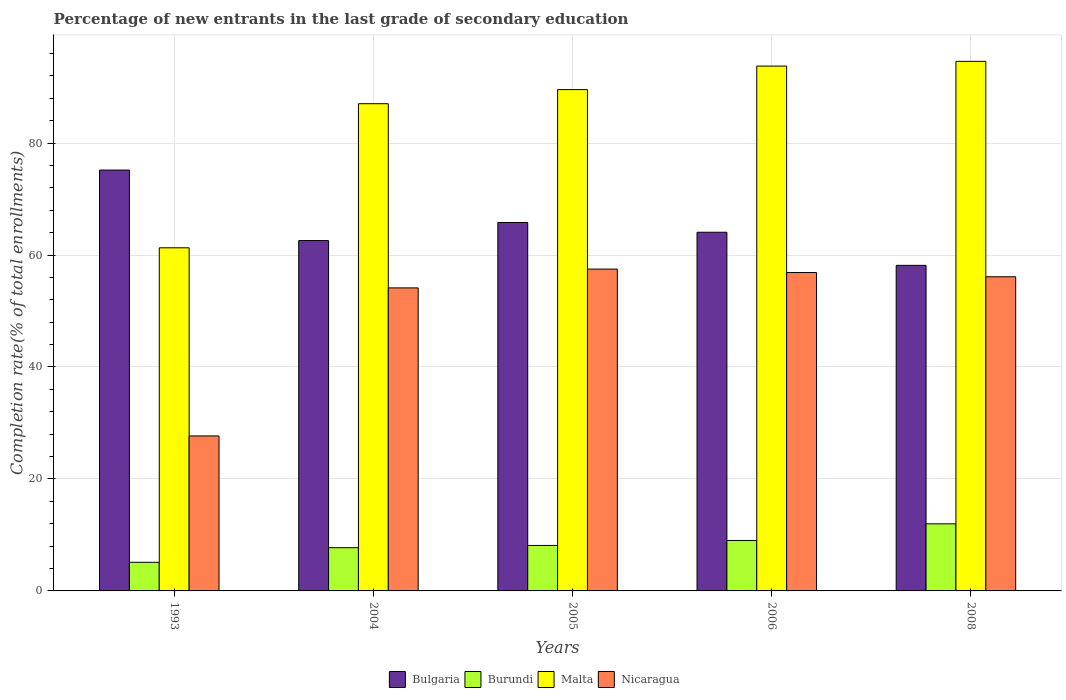Are the number of bars on each tick of the X-axis equal?
Ensure brevity in your answer.  Yes. What is the label of the 3rd group of bars from the left?
Ensure brevity in your answer.  2005. In how many cases, is the number of bars for a given year not equal to the number of legend labels?
Ensure brevity in your answer.  0. What is the percentage of new entrants in Burundi in 2008?
Give a very brief answer. 11.98. Across all years, what is the maximum percentage of new entrants in Nicaragua?
Your answer should be compact. 57.49. Across all years, what is the minimum percentage of new entrants in Bulgaria?
Provide a succinct answer. 58.15. What is the total percentage of new entrants in Burundi in the graph?
Your answer should be compact. 41.95. What is the difference between the percentage of new entrants in Malta in 2005 and that in 2008?
Give a very brief answer. -5.04. What is the difference between the percentage of new entrants in Burundi in 1993 and the percentage of new entrants in Bulgaria in 2005?
Offer a terse response. -60.7. What is the average percentage of new entrants in Burundi per year?
Your answer should be very brief. 8.39. In the year 2008, what is the difference between the percentage of new entrants in Bulgaria and percentage of new entrants in Burundi?
Give a very brief answer. 46.17. In how many years, is the percentage of new entrants in Nicaragua greater than 12 %?
Ensure brevity in your answer.  5. What is the ratio of the percentage of new entrants in Burundi in 2005 to that in 2008?
Your answer should be compact. 0.68. Is the difference between the percentage of new entrants in Bulgaria in 2005 and 2008 greater than the difference between the percentage of new entrants in Burundi in 2005 and 2008?
Your answer should be very brief. Yes. What is the difference between the highest and the second highest percentage of new entrants in Malta?
Keep it short and to the point. 0.84. What is the difference between the highest and the lowest percentage of new entrants in Malta?
Offer a very short reply. 33.31. In how many years, is the percentage of new entrants in Nicaragua greater than the average percentage of new entrants in Nicaragua taken over all years?
Your response must be concise. 4. Is the sum of the percentage of new entrants in Burundi in 2004 and 2008 greater than the maximum percentage of new entrants in Nicaragua across all years?
Ensure brevity in your answer.  No. What does the 1st bar from the left in 2005 represents?
Give a very brief answer. Bulgaria. Is it the case that in every year, the sum of the percentage of new entrants in Burundi and percentage of new entrants in Bulgaria is greater than the percentage of new entrants in Nicaragua?
Offer a terse response. Yes. How many bars are there?
Offer a very short reply. 20. Are all the bars in the graph horizontal?
Provide a succinct answer. No. How many years are there in the graph?
Your response must be concise. 5. What is the difference between two consecutive major ticks on the Y-axis?
Your answer should be compact. 20. How are the legend labels stacked?
Your answer should be compact. Horizontal. What is the title of the graph?
Provide a short and direct response. Percentage of new entrants in the last grade of secondary education. Does "Europe(all income levels)" appear as one of the legend labels in the graph?
Offer a very short reply. No. What is the label or title of the X-axis?
Give a very brief answer. Years. What is the label or title of the Y-axis?
Give a very brief answer. Completion rate(% of total enrollments). What is the Completion rate(% of total enrollments) in Bulgaria in 1993?
Ensure brevity in your answer.  75.18. What is the Completion rate(% of total enrollments) in Burundi in 1993?
Offer a terse response. 5.11. What is the Completion rate(% of total enrollments) of Malta in 1993?
Keep it short and to the point. 61.29. What is the Completion rate(% of total enrollments) in Nicaragua in 1993?
Provide a short and direct response. 27.68. What is the Completion rate(% of total enrollments) of Bulgaria in 2004?
Provide a short and direct response. 62.58. What is the Completion rate(% of total enrollments) in Burundi in 2004?
Give a very brief answer. 7.72. What is the Completion rate(% of total enrollments) of Malta in 2004?
Keep it short and to the point. 87.03. What is the Completion rate(% of total enrollments) in Nicaragua in 2004?
Ensure brevity in your answer.  54.13. What is the Completion rate(% of total enrollments) in Bulgaria in 2005?
Your answer should be compact. 65.81. What is the Completion rate(% of total enrollments) in Burundi in 2005?
Provide a short and direct response. 8.12. What is the Completion rate(% of total enrollments) in Malta in 2005?
Offer a very short reply. 89.55. What is the Completion rate(% of total enrollments) in Nicaragua in 2005?
Provide a short and direct response. 57.49. What is the Completion rate(% of total enrollments) in Bulgaria in 2006?
Provide a short and direct response. 64.07. What is the Completion rate(% of total enrollments) of Burundi in 2006?
Offer a terse response. 9.01. What is the Completion rate(% of total enrollments) of Malta in 2006?
Provide a succinct answer. 93.75. What is the Completion rate(% of total enrollments) of Nicaragua in 2006?
Provide a succinct answer. 56.87. What is the Completion rate(% of total enrollments) of Bulgaria in 2008?
Your answer should be very brief. 58.15. What is the Completion rate(% of total enrollments) of Burundi in 2008?
Offer a terse response. 11.98. What is the Completion rate(% of total enrollments) in Malta in 2008?
Provide a short and direct response. 94.59. What is the Completion rate(% of total enrollments) in Nicaragua in 2008?
Keep it short and to the point. 56.12. Across all years, what is the maximum Completion rate(% of total enrollments) in Bulgaria?
Provide a succinct answer. 75.18. Across all years, what is the maximum Completion rate(% of total enrollments) of Burundi?
Make the answer very short. 11.98. Across all years, what is the maximum Completion rate(% of total enrollments) in Malta?
Offer a terse response. 94.59. Across all years, what is the maximum Completion rate(% of total enrollments) in Nicaragua?
Ensure brevity in your answer.  57.49. Across all years, what is the minimum Completion rate(% of total enrollments) in Bulgaria?
Make the answer very short. 58.15. Across all years, what is the minimum Completion rate(% of total enrollments) of Burundi?
Give a very brief answer. 5.11. Across all years, what is the minimum Completion rate(% of total enrollments) in Malta?
Make the answer very short. 61.29. Across all years, what is the minimum Completion rate(% of total enrollments) of Nicaragua?
Keep it short and to the point. 27.68. What is the total Completion rate(% of total enrollments) in Bulgaria in the graph?
Offer a very short reply. 325.79. What is the total Completion rate(% of total enrollments) in Burundi in the graph?
Ensure brevity in your answer.  41.95. What is the total Completion rate(% of total enrollments) of Malta in the graph?
Make the answer very short. 426.2. What is the total Completion rate(% of total enrollments) of Nicaragua in the graph?
Your response must be concise. 252.28. What is the difference between the Completion rate(% of total enrollments) in Bulgaria in 1993 and that in 2004?
Provide a succinct answer. 12.59. What is the difference between the Completion rate(% of total enrollments) in Burundi in 1993 and that in 2004?
Keep it short and to the point. -2.61. What is the difference between the Completion rate(% of total enrollments) of Malta in 1993 and that in 2004?
Your answer should be very brief. -25.74. What is the difference between the Completion rate(% of total enrollments) in Nicaragua in 1993 and that in 2004?
Your answer should be very brief. -26.45. What is the difference between the Completion rate(% of total enrollments) in Bulgaria in 1993 and that in 2005?
Keep it short and to the point. 9.37. What is the difference between the Completion rate(% of total enrollments) in Burundi in 1993 and that in 2005?
Provide a short and direct response. -3.01. What is the difference between the Completion rate(% of total enrollments) of Malta in 1993 and that in 2005?
Give a very brief answer. -28.26. What is the difference between the Completion rate(% of total enrollments) in Nicaragua in 1993 and that in 2005?
Provide a short and direct response. -29.81. What is the difference between the Completion rate(% of total enrollments) of Bulgaria in 1993 and that in 2006?
Offer a very short reply. 11.11. What is the difference between the Completion rate(% of total enrollments) of Burundi in 1993 and that in 2006?
Give a very brief answer. -3.9. What is the difference between the Completion rate(% of total enrollments) in Malta in 1993 and that in 2006?
Provide a succinct answer. -32.46. What is the difference between the Completion rate(% of total enrollments) of Nicaragua in 1993 and that in 2006?
Ensure brevity in your answer.  -29.19. What is the difference between the Completion rate(% of total enrollments) of Bulgaria in 1993 and that in 2008?
Your answer should be compact. 17.02. What is the difference between the Completion rate(% of total enrollments) of Burundi in 1993 and that in 2008?
Your answer should be very brief. -6.87. What is the difference between the Completion rate(% of total enrollments) of Malta in 1993 and that in 2008?
Your response must be concise. -33.31. What is the difference between the Completion rate(% of total enrollments) in Nicaragua in 1993 and that in 2008?
Provide a succinct answer. -28.44. What is the difference between the Completion rate(% of total enrollments) of Bulgaria in 2004 and that in 2005?
Offer a very short reply. -3.23. What is the difference between the Completion rate(% of total enrollments) of Burundi in 2004 and that in 2005?
Offer a terse response. -0.4. What is the difference between the Completion rate(% of total enrollments) in Malta in 2004 and that in 2005?
Ensure brevity in your answer.  -2.52. What is the difference between the Completion rate(% of total enrollments) of Nicaragua in 2004 and that in 2005?
Provide a short and direct response. -3.36. What is the difference between the Completion rate(% of total enrollments) in Bulgaria in 2004 and that in 2006?
Ensure brevity in your answer.  -1.49. What is the difference between the Completion rate(% of total enrollments) in Burundi in 2004 and that in 2006?
Ensure brevity in your answer.  -1.29. What is the difference between the Completion rate(% of total enrollments) of Malta in 2004 and that in 2006?
Provide a short and direct response. -6.72. What is the difference between the Completion rate(% of total enrollments) of Nicaragua in 2004 and that in 2006?
Make the answer very short. -2.75. What is the difference between the Completion rate(% of total enrollments) in Bulgaria in 2004 and that in 2008?
Keep it short and to the point. 4.43. What is the difference between the Completion rate(% of total enrollments) in Burundi in 2004 and that in 2008?
Your response must be concise. -4.26. What is the difference between the Completion rate(% of total enrollments) in Malta in 2004 and that in 2008?
Provide a succinct answer. -7.57. What is the difference between the Completion rate(% of total enrollments) of Nicaragua in 2004 and that in 2008?
Your answer should be very brief. -1.99. What is the difference between the Completion rate(% of total enrollments) of Bulgaria in 2005 and that in 2006?
Your response must be concise. 1.74. What is the difference between the Completion rate(% of total enrollments) in Burundi in 2005 and that in 2006?
Provide a short and direct response. -0.89. What is the difference between the Completion rate(% of total enrollments) of Malta in 2005 and that in 2006?
Give a very brief answer. -4.2. What is the difference between the Completion rate(% of total enrollments) of Nicaragua in 2005 and that in 2006?
Provide a succinct answer. 0.62. What is the difference between the Completion rate(% of total enrollments) in Bulgaria in 2005 and that in 2008?
Provide a succinct answer. 7.65. What is the difference between the Completion rate(% of total enrollments) of Burundi in 2005 and that in 2008?
Provide a short and direct response. -3.86. What is the difference between the Completion rate(% of total enrollments) of Malta in 2005 and that in 2008?
Offer a very short reply. -5.04. What is the difference between the Completion rate(% of total enrollments) of Nicaragua in 2005 and that in 2008?
Offer a terse response. 1.37. What is the difference between the Completion rate(% of total enrollments) in Bulgaria in 2006 and that in 2008?
Keep it short and to the point. 5.91. What is the difference between the Completion rate(% of total enrollments) of Burundi in 2006 and that in 2008?
Your answer should be compact. -2.97. What is the difference between the Completion rate(% of total enrollments) in Malta in 2006 and that in 2008?
Provide a succinct answer. -0.84. What is the difference between the Completion rate(% of total enrollments) of Nicaragua in 2006 and that in 2008?
Your answer should be very brief. 0.76. What is the difference between the Completion rate(% of total enrollments) of Bulgaria in 1993 and the Completion rate(% of total enrollments) of Burundi in 2004?
Give a very brief answer. 67.46. What is the difference between the Completion rate(% of total enrollments) in Bulgaria in 1993 and the Completion rate(% of total enrollments) in Malta in 2004?
Your answer should be very brief. -11.85. What is the difference between the Completion rate(% of total enrollments) of Bulgaria in 1993 and the Completion rate(% of total enrollments) of Nicaragua in 2004?
Make the answer very short. 21.05. What is the difference between the Completion rate(% of total enrollments) of Burundi in 1993 and the Completion rate(% of total enrollments) of Malta in 2004?
Offer a very short reply. -81.91. What is the difference between the Completion rate(% of total enrollments) in Burundi in 1993 and the Completion rate(% of total enrollments) in Nicaragua in 2004?
Offer a terse response. -49.01. What is the difference between the Completion rate(% of total enrollments) in Malta in 1993 and the Completion rate(% of total enrollments) in Nicaragua in 2004?
Your response must be concise. 7.16. What is the difference between the Completion rate(% of total enrollments) in Bulgaria in 1993 and the Completion rate(% of total enrollments) in Burundi in 2005?
Make the answer very short. 67.05. What is the difference between the Completion rate(% of total enrollments) of Bulgaria in 1993 and the Completion rate(% of total enrollments) of Malta in 2005?
Your response must be concise. -14.37. What is the difference between the Completion rate(% of total enrollments) in Bulgaria in 1993 and the Completion rate(% of total enrollments) in Nicaragua in 2005?
Your response must be concise. 17.69. What is the difference between the Completion rate(% of total enrollments) of Burundi in 1993 and the Completion rate(% of total enrollments) of Malta in 2005?
Provide a short and direct response. -84.43. What is the difference between the Completion rate(% of total enrollments) in Burundi in 1993 and the Completion rate(% of total enrollments) in Nicaragua in 2005?
Your answer should be compact. -52.37. What is the difference between the Completion rate(% of total enrollments) in Malta in 1993 and the Completion rate(% of total enrollments) in Nicaragua in 2005?
Offer a very short reply. 3.8. What is the difference between the Completion rate(% of total enrollments) in Bulgaria in 1993 and the Completion rate(% of total enrollments) in Burundi in 2006?
Your answer should be very brief. 66.17. What is the difference between the Completion rate(% of total enrollments) of Bulgaria in 1993 and the Completion rate(% of total enrollments) of Malta in 2006?
Your response must be concise. -18.57. What is the difference between the Completion rate(% of total enrollments) of Bulgaria in 1993 and the Completion rate(% of total enrollments) of Nicaragua in 2006?
Make the answer very short. 18.3. What is the difference between the Completion rate(% of total enrollments) in Burundi in 1993 and the Completion rate(% of total enrollments) in Malta in 2006?
Provide a succinct answer. -88.64. What is the difference between the Completion rate(% of total enrollments) in Burundi in 1993 and the Completion rate(% of total enrollments) in Nicaragua in 2006?
Make the answer very short. -51.76. What is the difference between the Completion rate(% of total enrollments) of Malta in 1993 and the Completion rate(% of total enrollments) of Nicaragua in 2006?
Keep it short and to the point. 4.42. What is the difference between the Completion rate(% of total enrollments) in Bulgaria in 1993 and the Completion rate(% of total enrollments) in Burundi in 2008?
Give a very brief answer. 63.19. What is the difference between the Completion rate(% of total enrollments) in Bulgaria in 1993 and the Completion rate(% of total enrollments) in Malta in 2008?
Your answer should be very brief. -19.42. What is the difference between the Completion rate(% of total enrollments) in Bulgaria in 1993 and the Completion rate(% of total enrollments) in Nicaragua in 2008?
Provide a succinct answer. 19.06. What is the difference between the Completion rate(% of total enrollments) of Burundi in 1993 and the Completion rate(% of total enrollments) of Malta in 2008?
Your response must be concise. -89.48. What is the difference between the Completion rate(% of total enrollments) of Burundi in 1993 and the Completion rate(% of total enrollments) of Nicaragua in 2008?
Your answer should be compact. -51. What is the difference between the Completion rate(% of total enrollments) of Malta in 1993 and the Completion rate(% of total enrollments) of Nicaragua in 2008?
Your answer should be compact. 5.17. What is the difference between the Completion rate(% of total enrollments) in Bulgaria in 2004 and the Completion rate(% of total enrollments) in Burundi in 2005?
Give a very brief answer. 54.46. What is the difference between the Completion rate(% of total enrollments) of Bulgaria in 2004 and the Completion rate(% of total enrollments) of Malta in 2005?
Your answer should be compact. -26.96. What is the difference between the Completion rate(% of total enrollments) in Bulgaria in 2004 and the Completion rate(% of total enrollments) in Nicaragua in 2005?
Give a very brief answer. 5.1. What is the difference between the Completion rate(% of total enrollments) of Burundi in 2004 and the Completion rate(% of total enrollments) of Malta in 2005?
Keep it short and to the point. -81.83. What is the difference between the Completion rate(% of total enrollments) in Burundi in 2004 and the Completion rate(% of total enrollments) in Nicaragua in 2005?
Provide a succinct answer. -49.77. What is the difference between the Completion rate(% of total enrollments) of Malta in 2004 and the Completion rate(% of total enrollments) of Nicaragua in 2005?
Your response must be concise. 29.54. What is the difference between the Completion rate(% of total enrollments) in Bulgaria in 2004 and the Completion rate(% of total enrollments) in Burundi in 2006?
Your answer should be compact. 53.57. What is the difference between the Completion rate(% of total enrollments) in Bulgaria in 2004 and the Completion rate(% of total enrollments) in Malta in 2006?
Your answer should be very brief. -31.17. What is the difference between the Completion rate(% of total enrollments) in Bulgaria in 2004 and the Completion rate(% of total enrollments) in Nicaragua in 2006?
Ensure brevity in your answer.  5.71. What is the difference between the Completion rate(% of total enrollments) of Burundi in 2004 and the Completion rate(% of total enrollments) of Malta in 2006?
Give a very brief answer. -86.03. What is the difference between the Completion rate(% of total enrollments) in Burundi in 2004 and the Completion rate(% of total enrollments) in Nicaragua in 2006?
Offer a terse response. -49.15. What is the difference between the Completion rate(% of total enrollments) of Malta in 2004 and the Completion rate(% of total enrollments) of Nicaragua in 2006?
Ensure brevity in your answer.  30.16. What is the difference between the Completion rate(% of total enrollments) in Bulgaria in 2004 and the Completion rate(% of total enrollments) in Burundi in 2008?
Keep it short and to the point. 50.6. What is the difference between the Completion rate(% of total enrollments) of Bulgaria in 2004 and the Completion rate(% of total enrollments) of Malta in 2008?
Provide a succinct answer. -32.01. What is the difference between the Completion rate(% of total enrollments) of Bulgaria in 2004 and the Completion rate(% of total enrollments) of Nicaragua in 2008?
Provide a succinct answer. 6.47. What is the difference between the Completion rate(% of total enrollments) of Burundi in 2004 and the Completion rate(% of total enrollments) of Malta in 2008?
Make the answer very short. -86.87. What is the difference between the Completion rate(% of total enrollments) of Burundi in 2004 and the Completion rate(% of total enrollments) of Nicaragua in 2008?
Offer a terse response. -48.4. What is the difference between the Completion rate(% of total enrollments) of Malta in 2004 and the Completion rate(% of total enrollments) of Nicaragua in 2008?
Your answer should be very brief. 30.91. What is the difference between the Completion rate(% of total enrollments) of Bulgaria in 2005 and the Completion rate(% of total enrollments) of Burundi in 2006?
Offer a terse response. 56.8. What is the difference between the Completion rate(% of total enrollments) of Bulgaria in 2005 and the Completion rate(% of total enrollments) of Malta in 2006?
Give a very brief answer. -27.94. What is the difference between the Completion rate(% of total enrollments) of Bulgaria in 2005 and the Completion rate(% of total enrollments) of Nicaragua in 2006?
Provide a short and direct response. 8.94. What is the difference between the Completion rate(% of total enrollments) of Burundi in 2005 and the Completion rate(% of total enrollments) of Malta in 2006?
Keep it short and to the point. -85.62. What is the difference between the Completion rate(% of total enrollments) of Burundi in 2005 and the Completion rate(% of total enrollments) of Nicaragua in 2006?
Your answer should be very brief. -48.75. What is the difference between the Completion rate(% of total enrollments) in Malta in 2005 and the Completion rate(% of total enrollments) in Nicaragua in 2006?
Offer a terse response. 32.68. What is the difference between the Completion rate(% of total enrollments) of Bulgaria in 2005 and the Completion rate(% of total enrollments) of Burundi in 2008?
Offer a terse response. 53.82. What is the difference between the Completion rate(% of total enrollments) in Bulgaria in 2005 and the Completion rate(% of total enrollments) in Malta in 2008?
Your answer should be compact. -28.78. What is the difference between the Completion rate(% of total enrollments) of Bulgaria in 2005 and the Completion rate(% of total enrollments) of Nicaragua in 2008?
Your response must be concise. 9.69. What is the difference between the Completion rate(% of total enrollments) of Burundi in 2005 and the Completion rate(% of total enrollments) of Malta in 2008?
Offer a terse response. -86.47. What is the difference between the Completion rate(% of total enrollments) in Burundi in 2005 and the Completion rate(% of total enrollments) in Nicaragua in 2008?
Your response must be concise. -47.99. What is the difference between the Completion rate(% of total enrollments) in Malta in 2005 and the Completion rate(% of total enrollments) in Nicaragua in 2008?
Your response must be concise. 33.43. What is the difference between the Completion rate(% of total enrollments) of Bulgaria in 2006 and the Completion rate(% of total enrollments) of Burundi in 2008?
Ensure brevity in your answer.  52.08. What is the difference between the Completion rate(% of total enrollments) in Bulgaria in 2006 and the Completion rate(% of total enrollments) in Malta in 2008?
Keep it short and to the point. -30.52. What is the difference between the Completion rate(% of total enrollments) of Bulgaria in 2006 and the Completion rate(% of total enrollments) of Nicaragua in 2008?
Your answer should be very brief. 7.95. What is the difference between the Completion rate(% of total enrollments) of Burundi in 2006 and the Completion rate(% of total enrollments) of Malta in 2008?
Make the answer very short. -85.58. What is the difference between the Completion rate(% of total enrollments) of Burundi in 2006 and the Completion rate(% of total enrollments) of Nicaragua in 2008?
Offer a terse response. -47.11. What is the difference between the Completion rate(% of total enrollments) in Malta in 2006 and the Completion rate(% of total enrollments) in Nicaragua in 2008?
Provide a succinct answer. 37.63. What is the average Completion rate(% of total enrollments) of Bulgaria per year?
Give a very brief answer. 65.16. What is the average Completion rate(% of total enrollments) in Burundi per year?
Offer a terse response. 8.39. What is the average Completion rate(% of total enrollments) of Malta per year?
Provide a succinct answer. 85.24. What is the average Completion rate(% of total enrollments) of Nicaragua per year?
Offer a very short reply. 50.46. In the year 1993, what is the difference between the Completion rate(% of total enrollments) of Bulgaria and Completion rate(% of total enrollments) of Burundi?
Your response must be concise. 70.06. In the year 1993, what is the difference between the Completion rate(% of total enrollments) of Bulgaria and Completion rate(% of total enrollments) of Malta?
Your answer should be compact. 13.89. In the year 1993, what is the difference between the Completion rate(% of total enrollments) of Bulgaria and Completion rate(% of total enrollments) of Nicaragua?
Ensure brevity in your answer.  47.5. In the year 1993, what is the difference between the Completion rate(% of total enrollments) of Burundi and Completion rate(% of total enrollments) of Malta?
Offer a terse response. -56.17. In the year 1993, what is the difference between the Completion rate(% of total enrollments) in Burundi and Completion rate(% of total enrollments) in Nicaragua?
Provide a succinct answer. -22.57. In the year 1993, what is the difference between the Completion rate(% of total enrollments) in Malta and Completion rate(% of total enrollments) in Nicaragua?
Provide a succinct answer. 33.61. In the year 2004, what is the difference between the Completion rate(% of total enrollments) of Bulgaria and Completion rate(% of total enrollments) of Burundi?
Your response must be concise. 54.86. In the year 2004, what is the difference between the Completion rate(% of total enrollments) of Bulgaria and Completion rate(% of total enrollments) of Malta?
Ensure brevity in your answer.  -24.44. In the year 2004, what is the difference between the Completion rate(% of total enrollments) of Bulgaria and Completion rate(% of total enrollments) of Nicaragua?
Your response must be concise. 8.46. In the year 2004, what is the difference between the Completion rate(% of total enrollments) in Burundi and Completion rate(% of total enrollments) in Malta?
Your answer should be compact. -79.31. In the year 2004, what is the difference between the Completion rate(% of total enrollments) in Burundi and Completion rate(% of total enrollments) in Nicaragua?
Provide a short and direct response. -46.41. In the year 2004, what is the difference between the Completion rate(% of total enrollments) in Malta and Completion rate(% of total enrollments) in Nicaragua?
Give a very brief answer. 32.9. In the year 2005, what is the difference between the Completion rate(% of total enrollments) in Bulgaria and Completion rate(% of total enrollments) in Burundi?
Your answer should be compact. 57.68. In the year 2005, what is the difference between the Completion rate(% of total enrollments) of Bulgaria and Completion rate(% of total enrollments) of Malta?
Make the answer very short. -23.74. In the year 2005, what is the difference between the Completion rate(% of total enrollments) in Bulgaria and Completion rate(% of total enrollments) in Nicaragua?
Your answer should be very brief. 8.32. In the year 2005, what is the difference between the Completion rate(% of total enrollments) of Burundi and Completion rate(% of total enrollments) of Malta?
Make the answer very short. -81.42. In the year 2005, what is the difference between the Completion rate(% of total enrollments) of Burundi and Completion rate(% of total enrollments) of Nicaragua?
Offer a very short reply. -49.36. In the year 2005, what is the difference between the Completion rate(% of total enrollments) in Malta and Completion rate(% of total enrollments) in Nicaragua?
Offer a terse response. 32.06. In the year 2006, what is the difference between the Completion rate(% of total enrollments) of Bulgaria and Completion rate(% of total enrollments) of Burundi?
Your response must be concise. 55.06. In the year 2006, what is the difference between the Completion rate(% of total enrollments) in Bulgaria and Completion rate(% of total enrollments) in Malta?
Keep it short and to the point. -29.68. In the year 2006, what is the difference between the Completion rate(% of total enrollments) of Bulgaria and Completion rate(% of total enrollments) of Nicaragua?
Give a very brief answer. 7.2. In the year 2006, what is the difference between the Completion rate(% of total enrollments) of Burundi and Completion rate(% of total enrollments) of Malta?
Ensure brevity in your answer.  -84.74. In the year 2006, what is the difference between the Completion rate(% of total enrollments) of Burundi and Completion rate(% of total enrollments) of Nicaragua?
Provide a succinct answer. -47.86. In the year 2006, what is the difference between the Completion rate(% of total enrollments) in Malta and Completion rate(% of total enrollments) in Nicaragua?
Your response must be concise. 36.88. In the year 2008, what is the difference between the Completion rate(% of total enrollments) in Bulgaria and Completion rate(% of total enrollments) in Burundi?
Ensure brevity in your answer.  46.17. In the year 2008, what is the difference between the Completion rate(% of total enrollments) of Bulgaria and Completion rate(% of total enrollments) of Malta?
Offer a terse response. -36.44. In the year 2008, what is the difference between the Completion rate(% of total enrollments) of Bulgaria and Completion rate(% of total enrollments) of Nicaragua?
Your response must be concise. 2.04. In the year 2008, what is the difference between the Completion rate(% of total enrollments) in Burundi and Completion rate(% of total enrollments) in Malta?
Your answer should be very brief. -82.61. In the year 2008, what is the difference between the Completion rate(% of total enrollments) in Burundi and Completion rate(% of total enrollments) in Nicaragua?
Your answer should be very brief. -44.13. In the year 2008, what is the difference between the Completion rate(% of total enrollments) in Malta and Completion rate(% of total enrollments) in Nicaragua?
Your answer should be very brief. 38.48. What is the ratio of the Completion rate(% of total enrollments) in Bulgaria in 1993 to that in 2004?
Provide a short and direct response. 1.2. What is the ratio of the Completion rate(% of total enrollments) of Burundi in 1993 to that in 2004?
Ensure brevity in your answer.  0.66. What is the ratio of the Completion rate(% of total enrollments) in Malta in 1993 to that in 2004?
Provide a short and direct response. 0.7. What is the ratio of the Completion rate(% of total enrollments) of Nicaragua in 1993 to that in 2004?
Ensure brevity in your answer.  0.51. What is the ratio of the Completion rate(% of total enrollments) of Bulgaria in 1993 to that in 2005?
Ensure brevity in your answer.  1.14. What is the ratio of the Completion rate(% of total enrollments) of Burundi in 1993 to that in 2005?
Keep it short and to the point. 0.63. What is the ratio of the Completion rate(% of total enrollments) of Malta in 1993 to that in 2005?
Offer a very short reply. 0.68. What is the ratio of the Completion rate(% of total enrollments) of Nicaragua in 1993 to that in 2005?
Offer a very short reply. 0.48. What is the ratio of the Completion rate(% of total enrollments) of Bulgaria in 1993 to that in 2006?
Your answer should be compact. 1.17. What is the ratio of the Completion rate(% of total enrollments) of Burundi in 1993 to that in 2006?
Provide a succinct answer. 0.57. What is the ratio of the Completion rate(% of total enrollments) of Malta in 1993 to that in 2006?
Offer a terse response. 0.65. What is the ratio of the Completion rate(% of total enrollments) in Nicaragua in 1993 to that in 2006?
Offer a very short reply. 0.49. What is the ratio of the Completion rate(% of total enrollments) in Bulgaria in 1993 to that in 2008?
Offer a very short reply. 1.29. What is the ratio of the Completion rate(% of total enrollments) of Burundi in 1993 to that in 2008?
Your answer should be compact. 0.43. What is the ratio of the Completion rate(% of total enrollments) of Malta in 1993 to that in 2008?
Your response must be concise. 0.65. What is the ratio of the Completion rate(% of total enrollments) of Nicaragua in 1993 to that in 2008?
Offer a terse response. 0.49. What is the ratio of the Completion rate(% of total enrollments) of Bulgaria in 2004 to that in 2005?
Offer a very short reply. 0.95. What is the ratio of the Completion rate(% of total enrollments) of Burundi in 2004 to that in 2005?
Offer a very short reply. 0.95. What is the ratio of the Completion rate(% of total enrollments) in Malta in 2004 to that in 2005?
Give a very brief answer. 0.97. What is the ratio of the Completion rate(% of total enrollments) in Nicaragua in 2004 to that in 2005?
Offer a very short reply. 0.94. What is the ratio of the Completion rate(% of total enrollments) in Bulgaria in 2004 to that in 2006?
Offer a terse response. 0.98. What is the ratio of the Completion rate(% of total enrollments) of Burundi in 2004 to that in 2006?
Offer a terse response. 0.86. What is the ratio of the Completion rate(% of total enrollments) in Malta in 2004 to that in 2006?
Your answer should be compact. 0.93. What is the ratio of the Completion rate(% of total enrollments) of Nicaragua in 2004 to that in 2006?
Your answer should be compact. 0.95. What is the ratio of the Completion rate(% of total enrollments) in Bulgaria in 2004 to that in 2008?
Offer a terse response. 1.08. What is the ratio of the Completion rate(% of total enrollments) of Burundi in 2004 to that in 2008?
Your answer should be compact. 0.64. What is the ratio of the Completion rate(% of total enrollments) of Malta in 2004 to that in 2008?
Offer a terse response. 0.92. What is the ratio of the Completion rate(% of total enrollments) of Nicaragua in 2004 to that in 2008?
Offer a very short reply. 0.96. What is the ratio of the Completion rate(% of total enrollments) in Bulgaria in 2005 to that in 2006?
Make the answer very short. 1.03. What is the ratio of the Completion rate(% of total enrollments) of Burundi in 2005 to that in 2006?
Make the answer very short. 0.9. What is the ratio of the Completion rate(% of total enrollments) of Malta in 2005 to that in 2006?
Give a very brief answer. 0.96. What is the ratio of the Completion rate(% of total enrollments) of Nicaragua in 2005 to that in 2006?
Your answer should be very brief. 1.01. What is the ratio of the Completion rate(% of total enrollments) in Bulgaria in 2005 to that in 2008?
Ensure brevity in your answer.  1.13. What is the ratio of the Completion rate(% of total enrollments) of Burundi in 2005 to that in 2008?
Provide a succinct answer. 0.68. What is the ratio of the Completion rate(% of total enrollments) of Malta in 2005 to that in 2008?
Provide a succinct answer. 0.95. What is the ratio of the Completion rate(% of total enrollments) in Nicaragua in 2005 to that in 2008?
Provide a succinct answer. 1.02. What is the ratio of the Completion rate(% of total enrollments) of Bulgaria in 2006 to that in 2008?
Your response must be concise. 1.1. What is the ratio of the Completion rate(% of total enrollments) in Burundi in 2006 to that in 2008?
Keep it short and to the point. 0.75. What is the ratio of the Completion rate(% of total enrollments) of Nicaragua in 2006 to that in 2008?
Your answer should be very brief. 1.01. What is the difference between the highest and the second highest Completion rate(% of total enrollments) of Bulgaria?
Your response must be concise. 9.37. What is the difference between the highest and the second highest Completion rate(% of total enrollments) of Burundi?
Give a very brief answer. 2.97. What is the difference between the highest and the second highest Completion rate(% of total enrollments) of Malta?
Provide a short and direct response. 0.84. What is the difference between the highest and the second highest Completion rate(% of total enrollments) in Nicaragua?
Provide a short and direct response. 0.62. What is the difference between the highest and the lowest Completion rate(% of total enrollments) of Bulgaria?
Make the answer very short. 17.02. What is the difference between the highest and the lowest Completion rate(% of total enrollments) in Burundi?
Give a very brief answer. 6.87. What is the difference between the highest and the lowest Completion rate(% of total enrollments) in Malta?
Give a very brief answer. 33.31. What is the difference between the highest and the lowest Completion rate(% of total enrollments) of Nicaragua?
Provide a short and direct response. 29.81. 